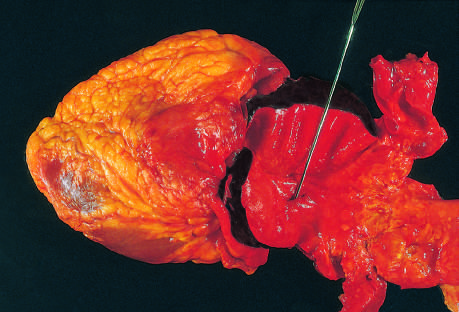what lies at the edge of a large area of atherosclerosis, which arrested the propagation of the dissection?
Answer the question using a single word or phrase. The distal edge of the intramural hematoma 